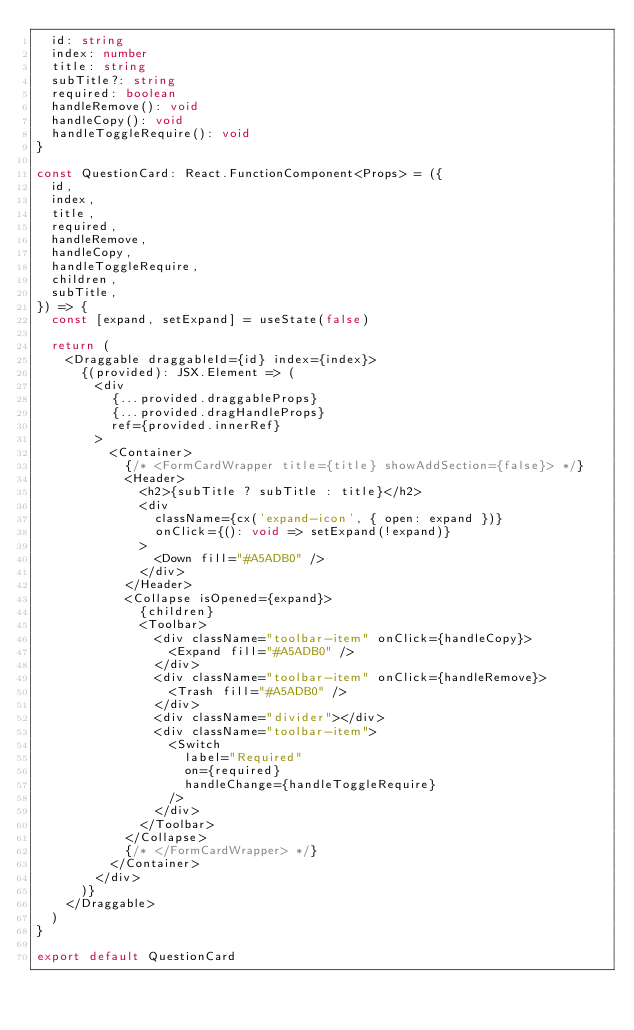<code> <loc_0><loc_0><loc_500><loc_500><_TypeScript_>  id: string
  index: number
  title: string
  subTitle?: string
  required: boolean
  handleRemove(): void
  handleCopy(): void
  handleToggleRequire(): void
}

const QuestionCard: React.FunctionComponent<Props> = ({
  id,
  index,
  title,
  required,
  handleRemove,
  handleCopy,
  handleToggleRequire,
  children,
  subTitle,
}) => {
  const [expand, setExpand] = useState(false)

  return (
    <Draggable draggableId={id} index={index}>
      {(provided): JSX.Element => (
        <div
          {...provided.draggableProps}
          {...provided.dragHandleProps}
          ref={provided.innerRef}
        >
          <Container>
            {/* <FormCardWrapper title={title} showAddSection={false}> */}
            <Header>
              <h2>{subTitle ? subTitle : title}</h2>
              <div
                className={cx('expand-icon', { open: expand })}
                onClick={(): void => setExpand(!expand)}
              >
                <Down fill="#A5ADB0" />
              </div>
            </Header>
            <Collapse isOpened={expand}>
              {children}
              <Toolbar>
                <div className="toolbar-item" onClick={handleCopy}>
                  <Expand fill="#A5ADB0" />
                </div>
                <div className="toolbar-item" onClick={handleRemove}>
                  <Trash fill="#A5ADB0" />
                </div>
                <div className="divider"></div>
                <div className="toolbar-item">
                  <Switch
                    label="Required"
                    on={required}
                    handleChange={handleToggleRequire}
                  />
                </div>
              </Toolbar>
            </Collapse>
            {/* </FormCardWrapper> */}
          </Container>
        </div>
      )}
    </Draggable>
  )
}

export default QuestionCard
</code> 